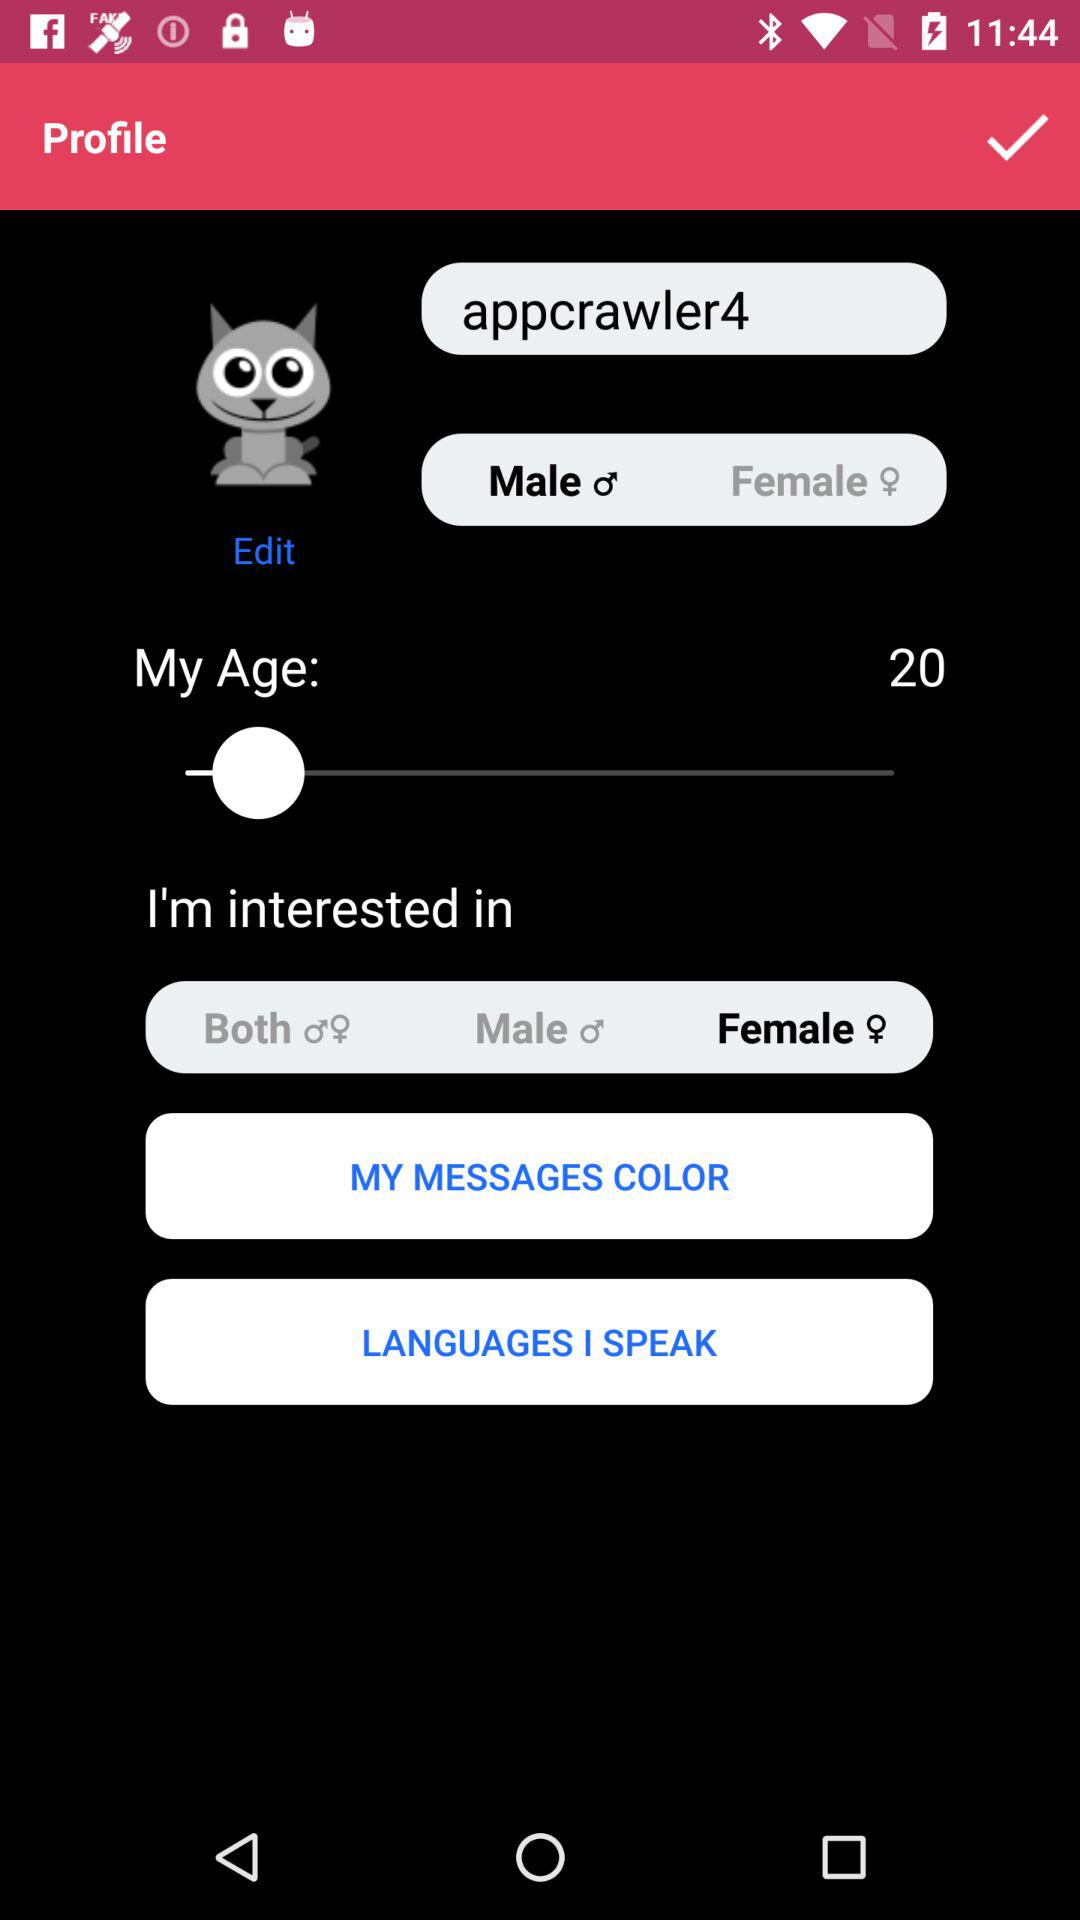What is the selected gender? The selected gender is female. 